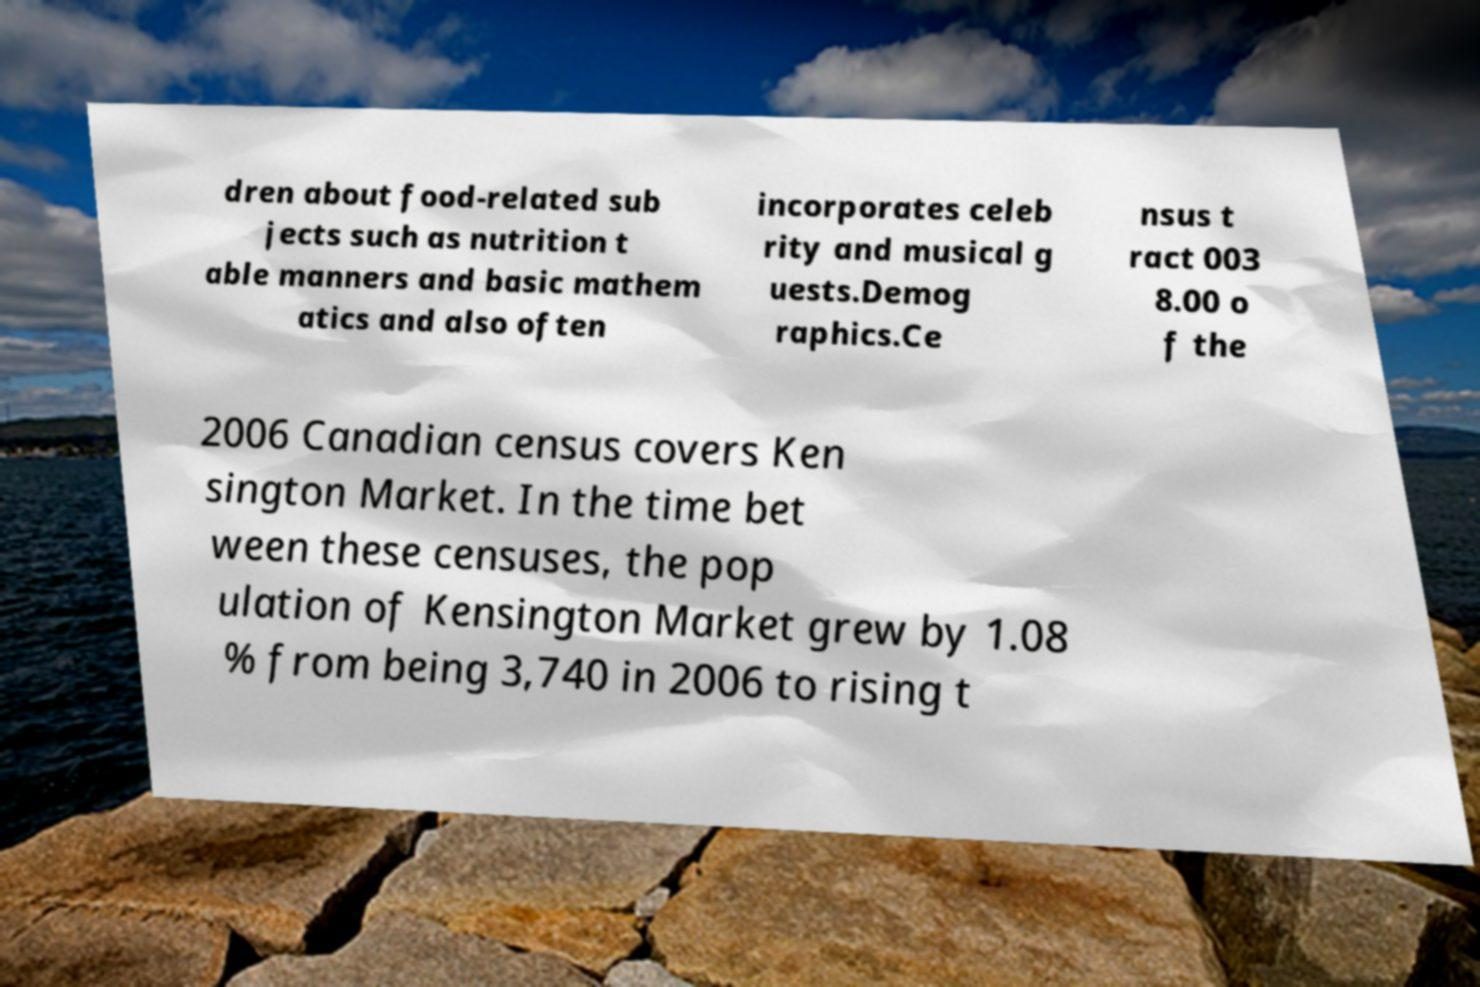There's text embedded in this image that I need extracted. Can you transcribe it verbatim? dren about food-related sub jects such as nutrition t able manners and basic mathem atics and also often incorporates celeb rity and musical g uests.Demog raphics.Ce nsus t ract 003 8.00 o f the 2006 Canadian census covers Ken sington Market. In the time bet ween these censuses, the pop ulation of Kensington Market grew by 1.08 % from being 3,740 in 2006 to rising t 